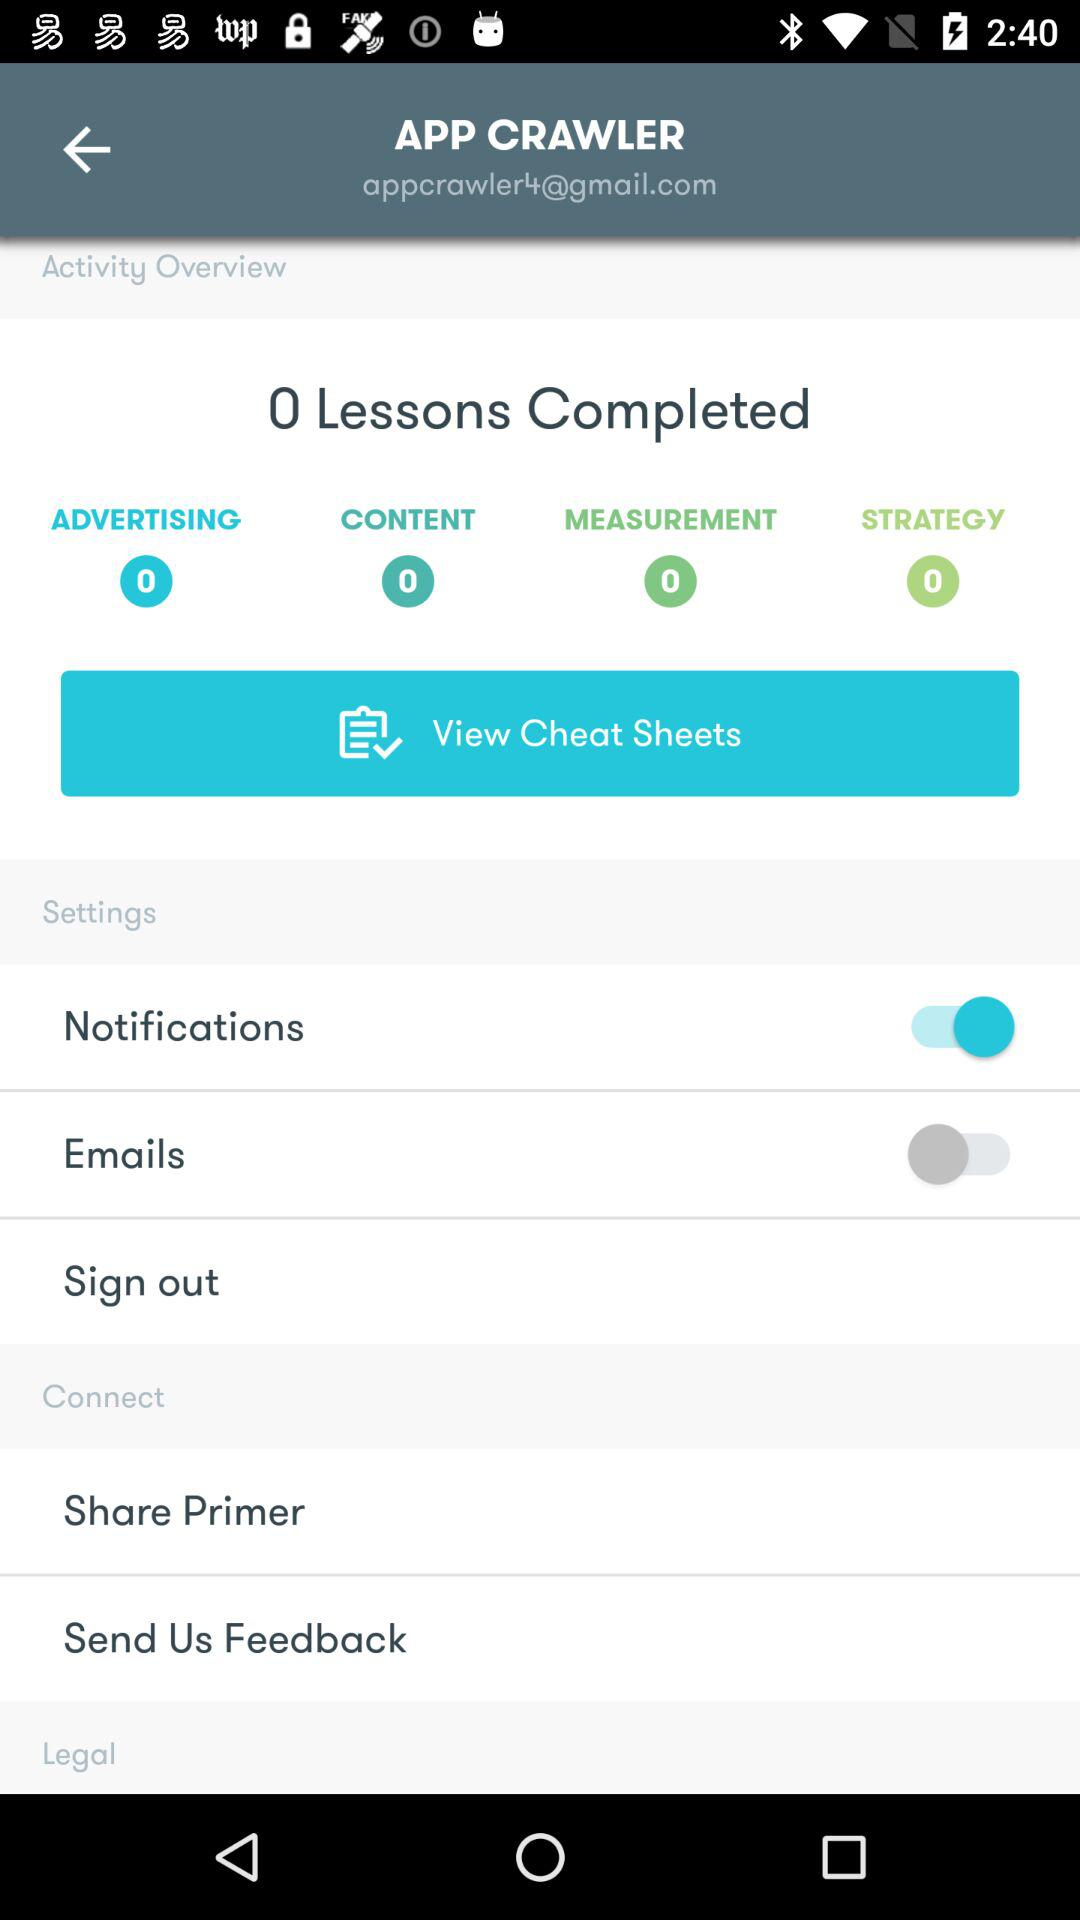How many lessons has the user completed?
Answer the question using a single word or phrase. 0 